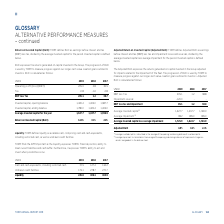According to Torm's financial document, How is average invested capital calculated? as the average of the opening and closing balance of invested capital. The document states: "¹ ⁾ Average invested capital is calculated as the average of the opening and closing balance of invested capital. ² ⁾ Average impairment is calculated..." Also, How is average impairment calculated? as the average of the opening and closing balances of impairment charges on vessels and goodwill in the balance sheet.. The document states: "sted capital. ² ⁾ Average impairment is calculated as the average of the opening and closing balances of impairment charges on vessels and goodwill in..." Also, For which years is the adjusted RoIC calculated in the table? The document contains multiple relevant values: 2019, 2018, 2017. From the document: "USDm 2019 2018 2017 USDm 2019 2018 2017 USDm 2019 2018 2017..." Additionally, In which year was the Average invested capital less average impairment the largest? According to the financial document, 2019. The relevant text states: "USDm 2019 2018 2017..." Also, can you calculate: What was the change in the Average invested capital less average impairment in 2019 from 2018? Based on the calculation: 1,725.9-1,622.7, the result is 103.2 (in millions). This is based on the information: "Average invested capital less average impairment 1,725.9 1,622.7 1,581.9 invested capital less average impairment 1,725.9 1,622.7 1,581.9..." The key data points involved are: 1,622.7, 1,725.9. Also, can you calculate: What was the percentage change in the Average invested capital less average impairment in 2019 from 2018? To answer this question, I need to perform calculations using the financial data. The calculation is: (1,725.9-1,622.7)/1,622.7, which equals 6.36 (percentage). This is based on the information: "Average invested capital less average impairment 1,725.9 1,622.7 1,581.9 invested capital less average impairment 1,725.9 1,622.7 1,581.9..." The key data points involved are: 1,622.7, 1,725.9. 